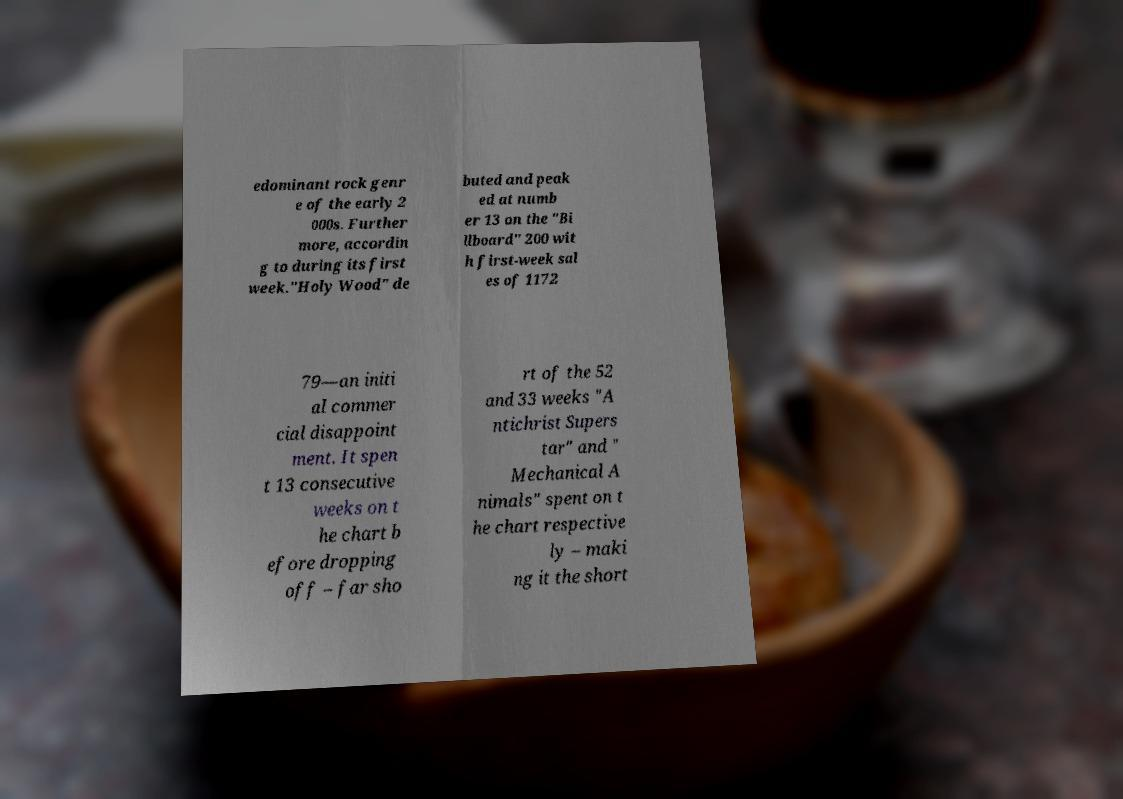Can you read and provide the text displayed in the image?This photo seems to have some interesting text. Can you extract and type it out for me? edominant rock genr e of the early 2 000s. Further more, accordin g to during its first week."Holy Wood" de buted and peak ed at numb er 13 on the "Bi llboard" 200 wit h first-week sal es of 1172 79—an initi al commer cial disappoint ment. It spen t 13 consecutive weeks on t he chart b efore dropping off – far sho rt of the 52 and 33 weeks "A ntichrist Supers tar" and " Mechanical A nimals" spent on t he chart respective ly – maki ng it the short 